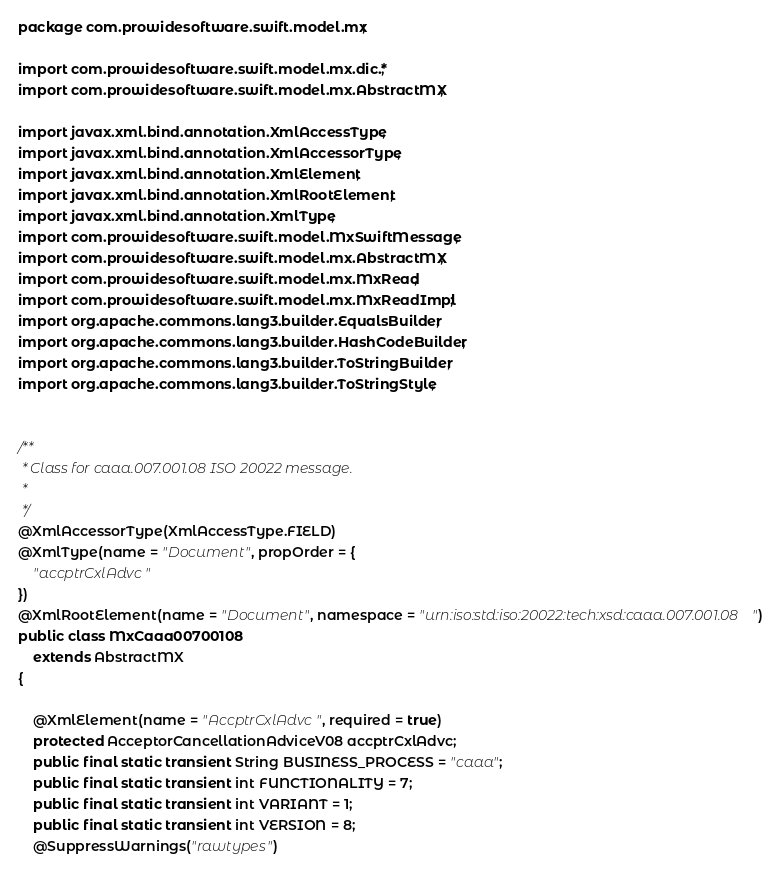Convert code to text. <code><loc_0><loc_0><loc_500><loc_500><_Java_>
package com.prowidesoftware.swift.model.mx;

import com.prowidesoftware.swift.model.mx.dic.*;
import com.prowidesoftware.swift.model.mx.AbstractMX;

import javax.xml.bind.annotation.XmlAccessType;
import javax.xml.bind.annotation.XmlAccessorType;
import javax.xml.bind.annotation.XmlElement;
import javax.xml.bind.annotation.XmlRootElement;
import javax.xml.bind.annotation.XmlType;
import com.prowidesoftware.swift.model.MxSwiftMessage;
import com.prowidesoftware.swift.model.mx.AbstractMX;
import com.prowidesoftware.swift.model.mx.MxRead;
import com.prowidesoftware.swift.model.mx.MxReadImpl;
import org.apache.commons.lang3.builder.EqualsBuilder;
import org.apache.commons.lang3.builder.HashCodeBuilder;
import org.apache.commons.lang3.builder.ToStringBuilder;
import org.apache.commons.lang3.builder.ToStringStyle;


/**
 * Class for caaa.007.001.08 ISO 20022 message.
 * 
 */
@XmlAccessorType(XmlAccessType.FIELD)
@XmlType(name = "Document", propOrder = {
    "accptrCxlAdvc"
})
@XmlRootElement(name = "Document", namespace = "urn:iso:std:iso:20022:tech:xsd:caaa.007.001.08")
public class MxCaaa00700108
    extends AbstractMX
{

    @XmlElement(name = "AccptrCxlAdvc", required = true)
    protected AcceptorCancellationAdviceV08 accptrCxlAdvc;
    public final static transient String BUSINESS_PROCESS = "caaa";
    public final static transient int FUNCTIONALITY = 7;
    public final static transient int VARIANT = 1;
    public final static transient int VERSION = 8;
    @SuppressWarnings("rawtypes")</code> 